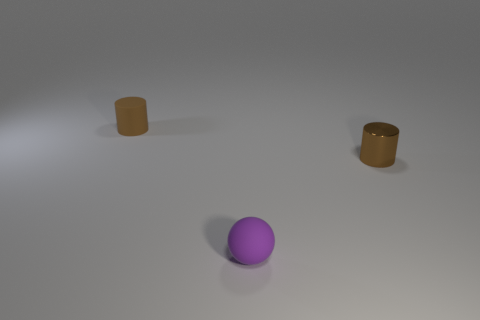What time of day does the lighting in the scene suggest? The lighting in the scene does not strongly suggest any specific time of day, as it is quite neutral and could be indicative of artificial indoor lighting. There are subtle shadows indicating a light source from above, but without more context or natural light indicators, it's difficult to pinpoint a time of day. 